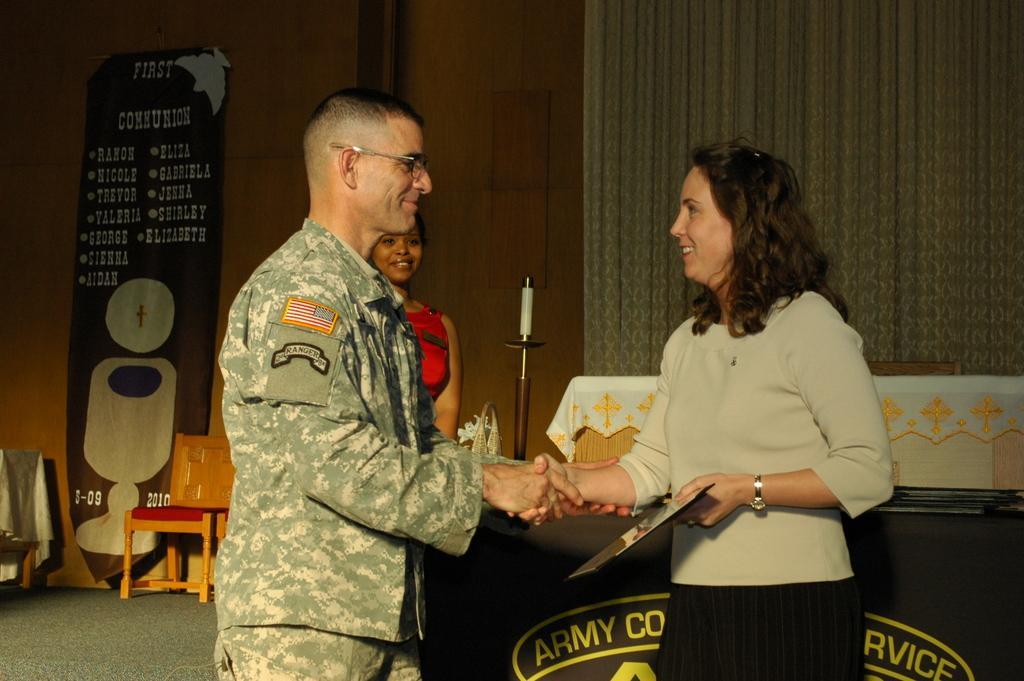In one or two sentences, can you explain what this image depicts? There are three persons in this image. The women at the right side is standing and smiling and shaking hand with the man standing opposite to the her. In background lady is standing is having smile on her face. At the left side there is a banner. At the right side white colour curtain and the table with the name written army. 